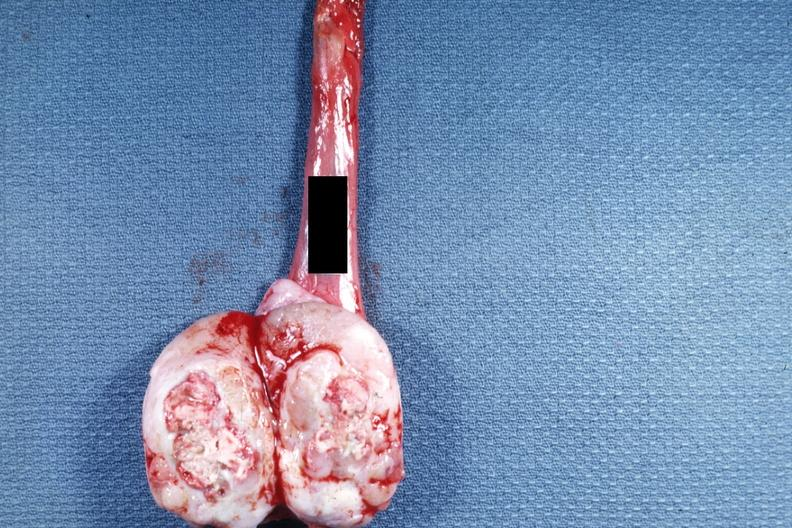s testicle present?
Answer the question using a single word or phrase. Yes 